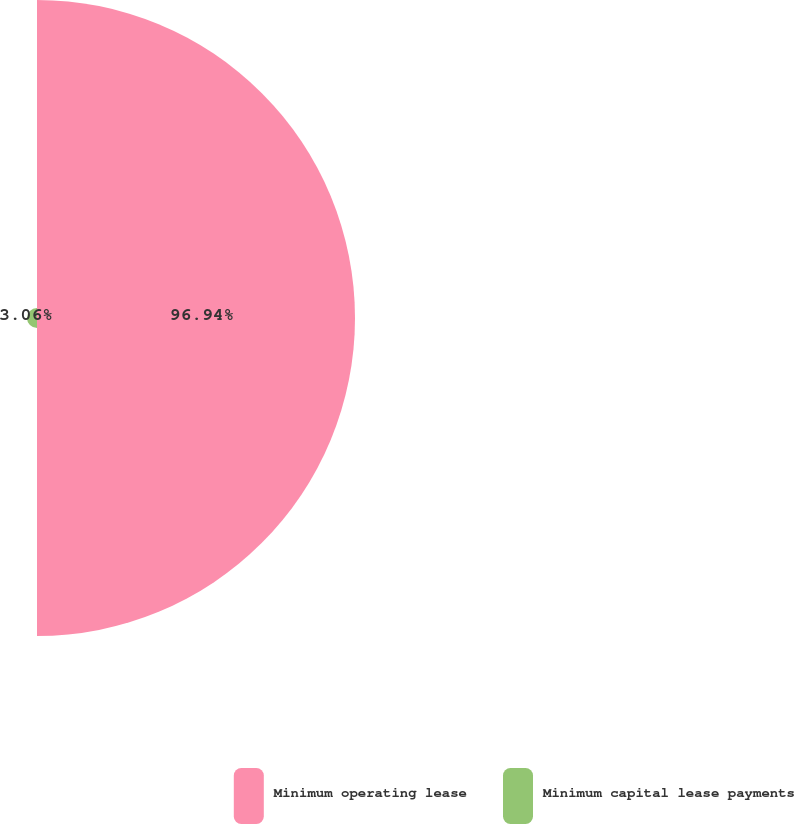<chart> <loc_0><loc_0><loc_500><loc_500><pie_chart><fcel>Minimum operating lease<fcel>Minimum capital lease payments<nl><fcel>96.94%<fcel>3.06%<nl></chart> 